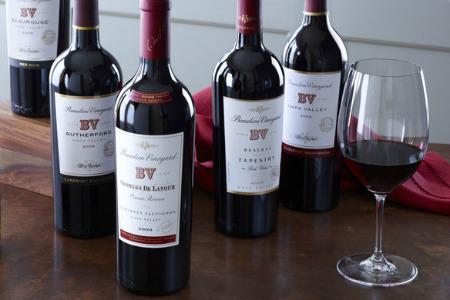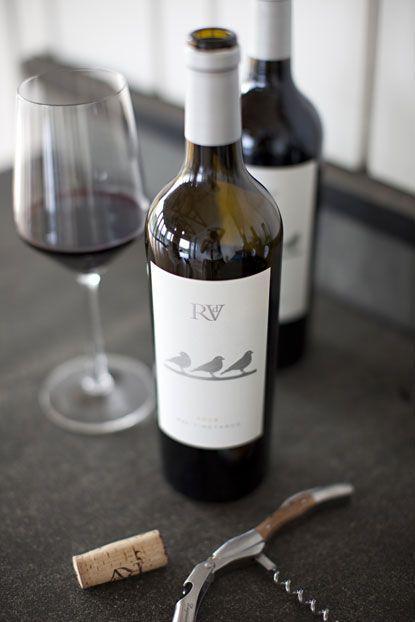The first image is the image on the left, the second image is the image on the right. For the images shown, is this caption "There is more than one wine glass in one of the images." true? Answer yes or no. No. 